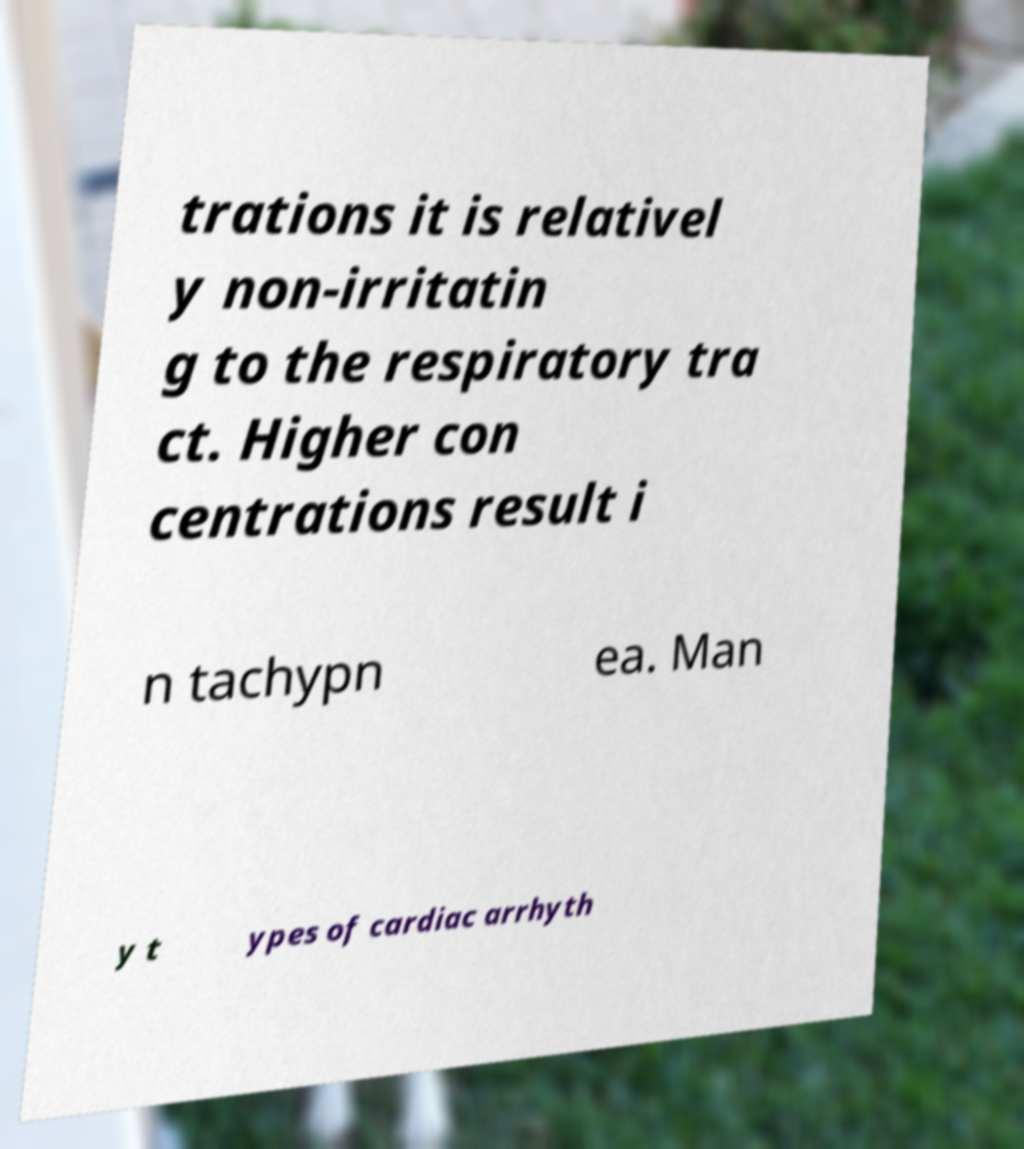Can you read and provide the text displayed in the image?This photo seems to have some interesting text. Can you extract and type it out for me? trations it is relativel y non-irritatin g to the respiratory tra ct. Higher con centrations result i n tachypn ea. Man y t ypes of cardiac arrhyth 